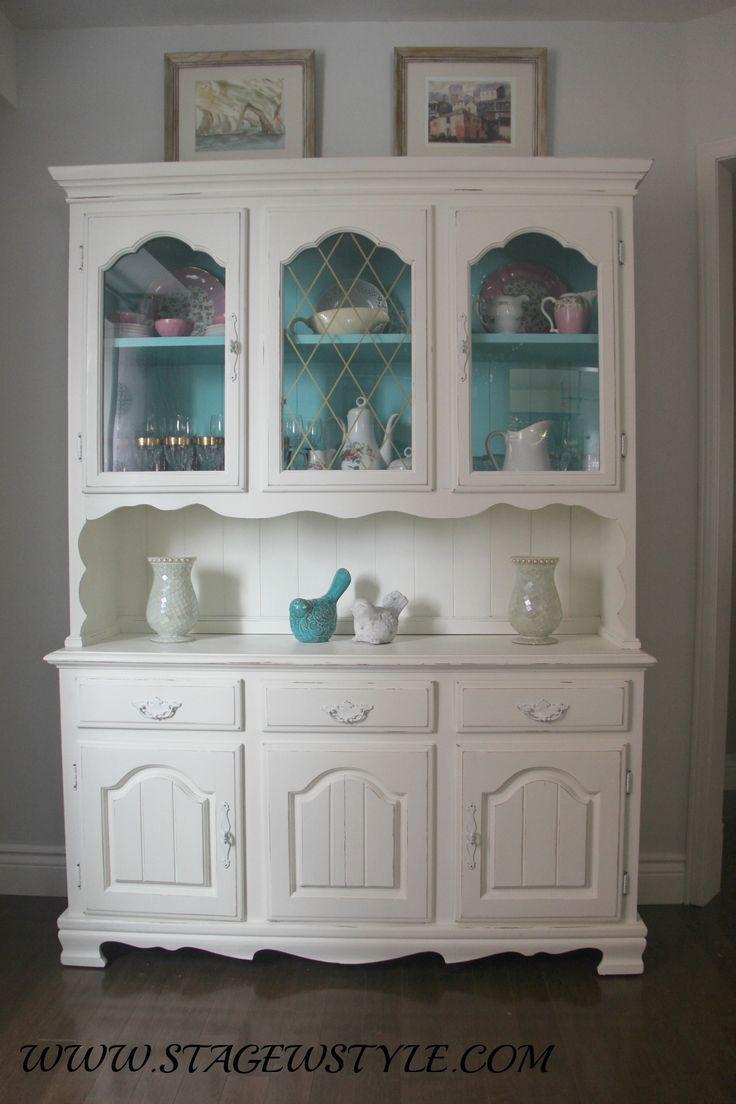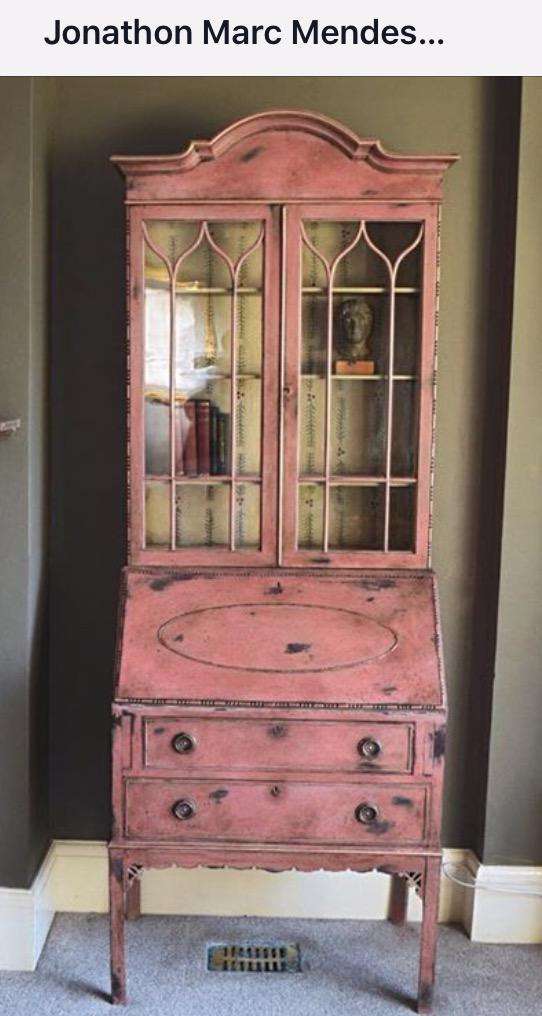The first image is the image on the left, the second image is the image on the right. For the images displayed, is the sentence "The cabinet in the right image has narrow legs and decorative curved top feature." factually correct? Answer yes or no. Yes. The first image is the image on the left, the second image is the image on the right. Evaluate the accuracy of this statement regarding the images: "An antique wooden piece in one image has a curved top, at least one glass door with an ornate window pane design, and sits on long thin legs.". Is it true? Answer yes or no. Yes. The first image is the image on the left, the second image is the image on the right. Evaluate the accuracy of this statement regarding the images: "The right image contains a blue china cabinet.". Is it true? Answer yes or no. No. 